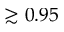<formula> <loc_0><loc_0><loc_500><loc_500>\gtrsim 0 . 9 5</formula> 